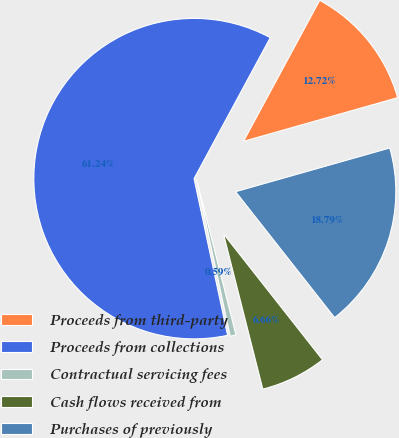Convert chart. <chart><loc_0><loc_0><loc_500><loc_500><pie_chart><fcel>Proceeds from third-party<fcel>Proceeds from collections<fcel>Contractual servicing fees<fcel>Cash flows received from<fcel>Purchases of previously<nl><fcel>12.72%<fcel>61.24%<fcel>0.59%<fcel>6.66%<fcel>18.79%<nl></chart> 